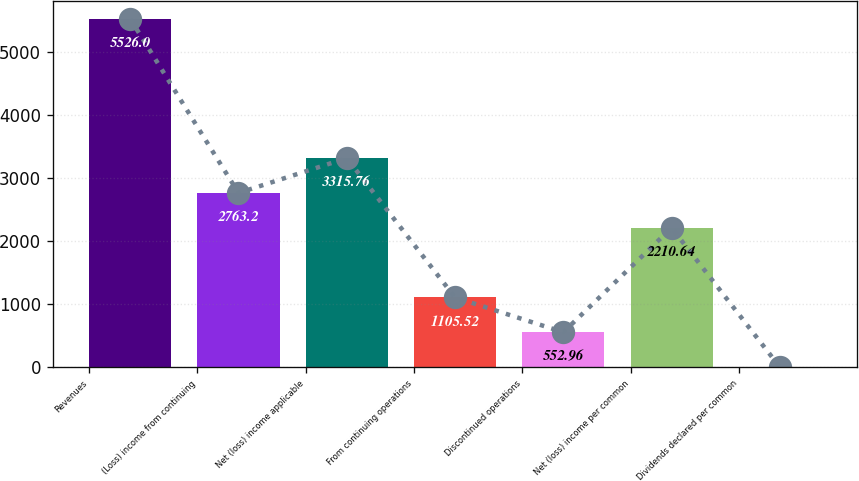Convert chart. <chart><loc_0><loc_0><loc_500><loc_500><bar_chart><fcel>Revenues<fcel>(Loss) income from continuing<fcel>Net (loss) income applicable<fcel>From continuing operations<fcel>Discontinued operations<fcel>Net (loss) income per common<fcel>Dividends declared per common<nl><fcel>5526<fcel>2763.2<fcel>3315.76<fcel>1105.52<fcel>552.96<fcel>2210.64<fcel>0.4<nl></chart> 